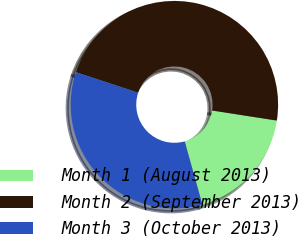<chart> <loc_0><loc_0><loc_500><loc_500><pie_chart><fcel>Month 1 (August 2013)<fcel>Month 2 (September 2013)<fcel>Month 3 (October 2013)<nl><fcel>18.2%<fcel>47.39%<fcel>34.41%<nl></chart> 